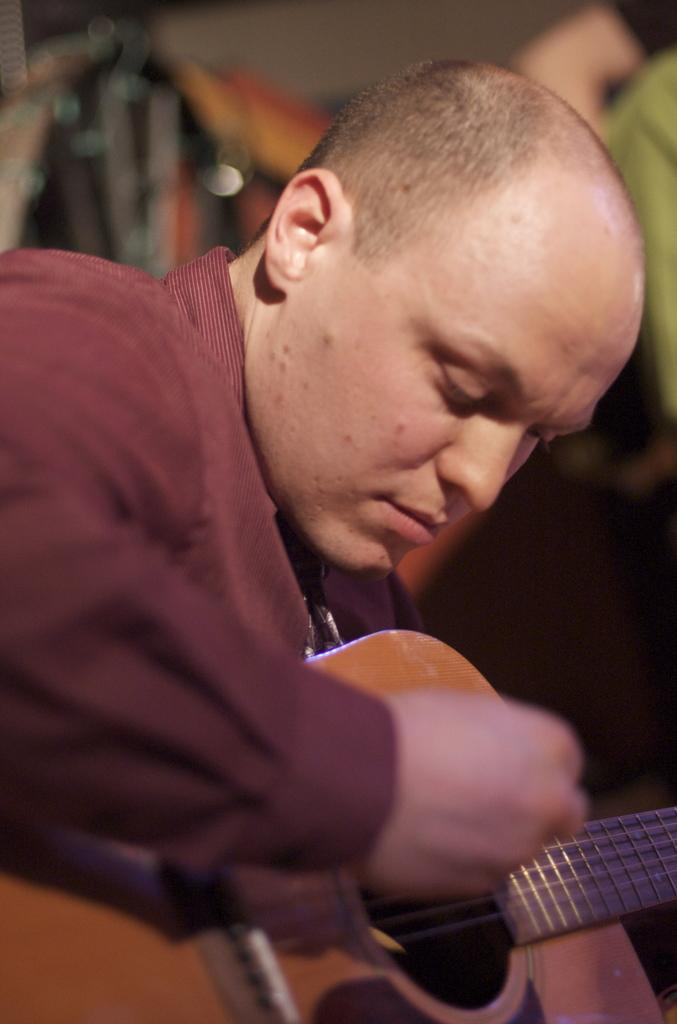What is the main subject of the image? There is a person in the image. What is the person doing in the image? The person is sitting. What object is the person holding in the image? The person is holding a guitar. What color is the shirt the person is wearing? The person is wearing a red shirt. How many rabbits can be seen in the image? There are no rabbits present in the image. What type of lead is the person using to play the guitar in the image? The image does not show the person playing the guitar, nor does it provide any information about the type of lead being used. 